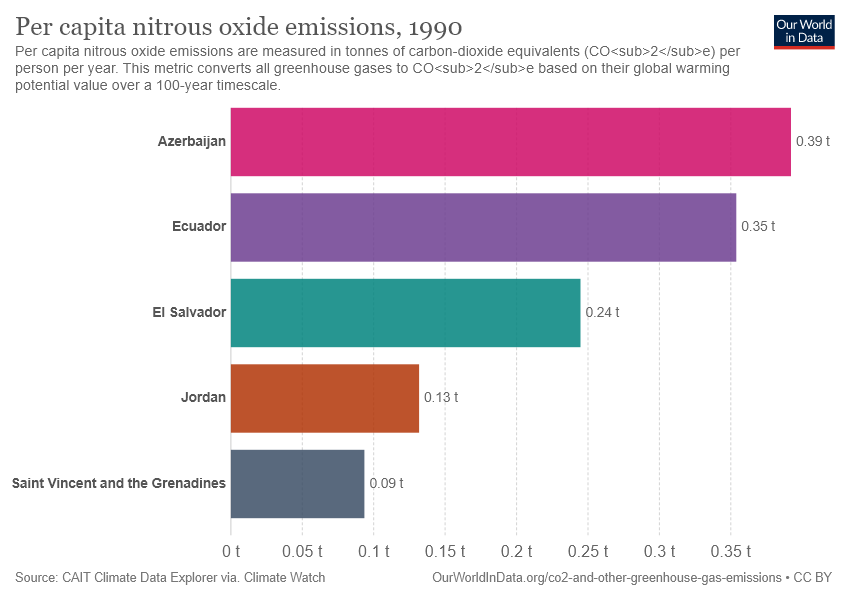Outline some significant characteristics in this image. The value of El Salvador is greater than the sum of the values of Jordan and Saint Vincent and the Grenadines. Jordan represents orange. 